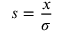<formula> <loc_0><loc_0><loc_500><loc_500>s = \frac { x } { \sigma }</formula> 